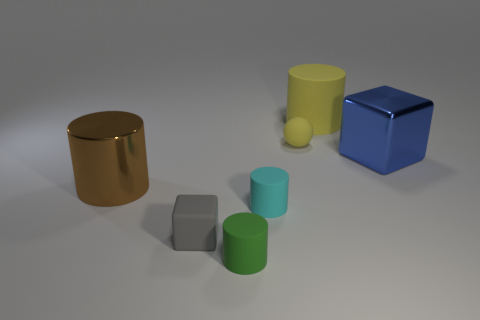Subtract 1 cylinders. How many cylinders are left? 3 Subtract all matte cylinders. How many cylinders are left? 1 Add 2 gray rubber blocks. How many objects exist? 9 Subtract all balls. How many objects are left? 6 Add 4 tiny gray balls. How many tiny gray balls exist? 4 Subtract 0 red blocks. How many objects are left? 7 Subtract all tiny cyan cylinders. Subtract all blocks. How many objects are left? 4 Add 2 green cylinders. How many green cylinders are left? 3 